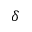Convert formula to latex. <formula><loc_0><loc_0><loc_500><loc_500>\delta</formula> 